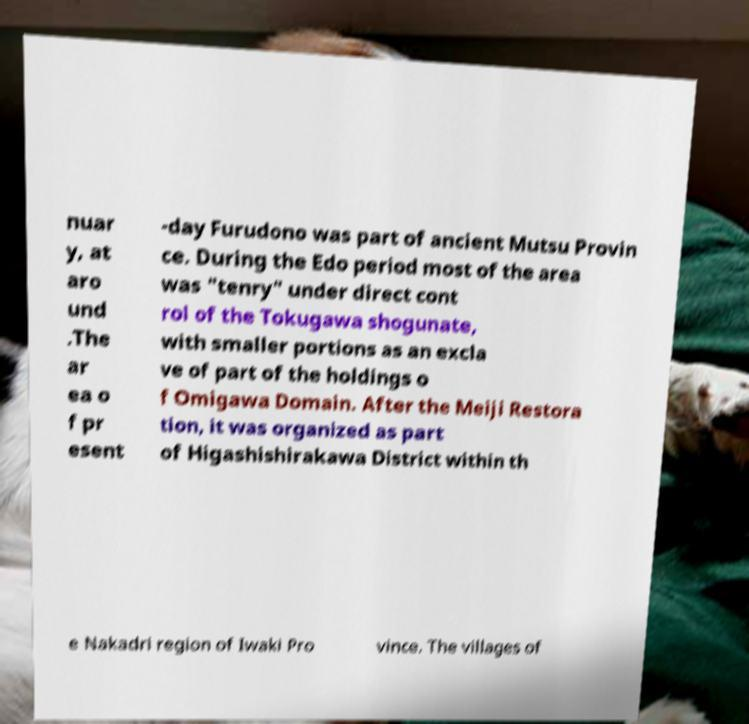Please read and relay the text visible in this image. What does it say? nuar y, at aro und .The ar ea o f pr esent -day Furudono was part of ancient Mutsu Provin ce. During the Edo period most of the area was "tenry" under direct cont rol of the Tokugawa shogunate, with smaller portions as an excla ve of part of the holdings o f Omigawa Domain. After the Meiji Restora tion, it was organized as part of Higashishirakawa District within th e Nakadri region of Iwaki Pro vince. The villages of 